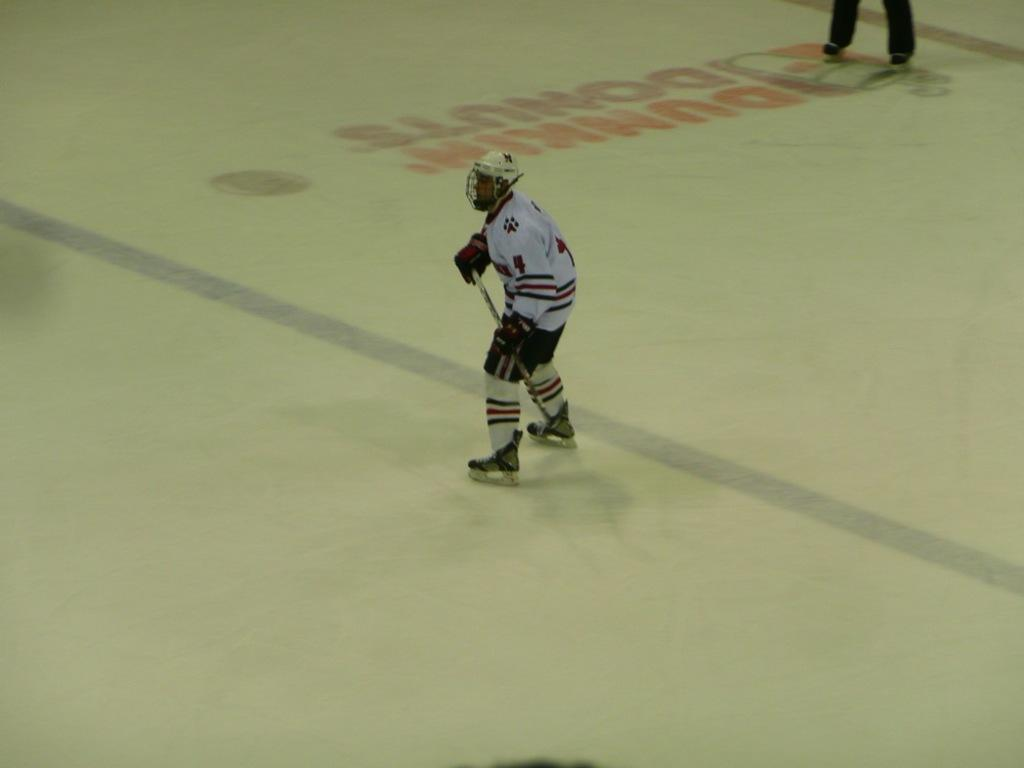<image>
Relay a brief, clear account of the picture shown. Dunkin Donuts is a sponsor of the home ice hockey team. 